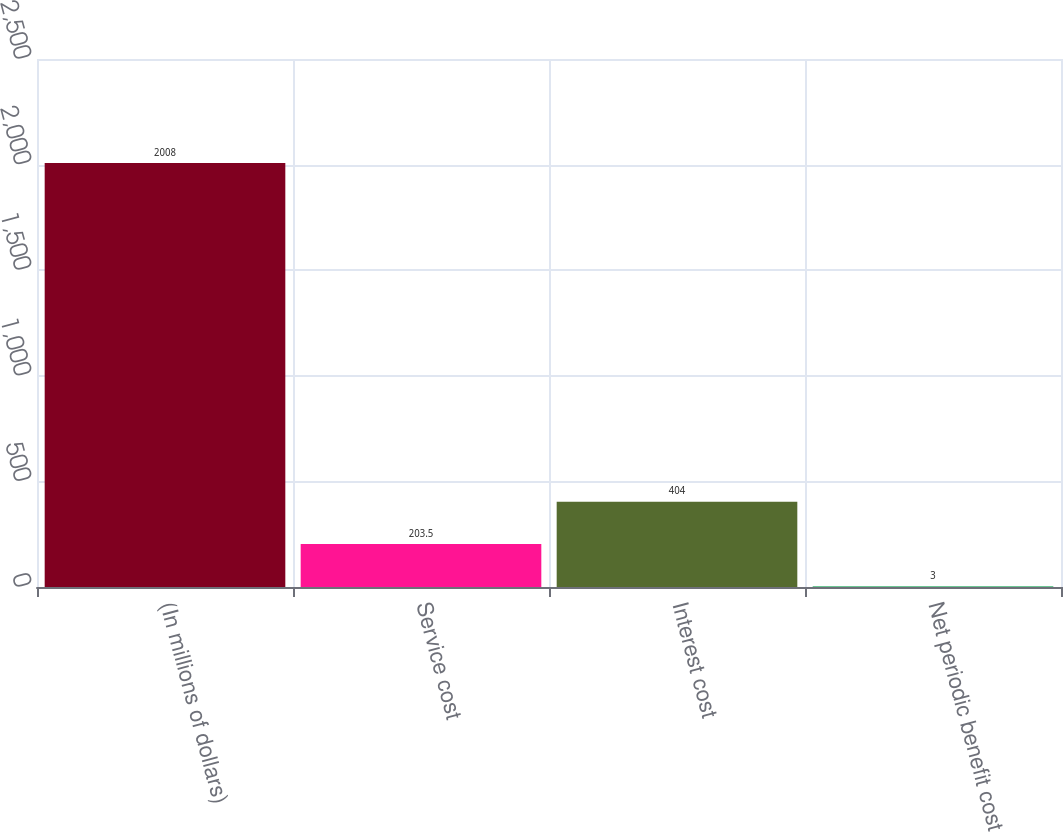Convert chart. <chart><loc_0><loc_0><loc_500><loc_500><bar_chart><fcel>(In millions of dollars)<fcel>Service cost<fcel>Interest cost<fcel>Net periodic benefit cost<nl><fcel>2008<fcel>203.5<fcel>404<fcel>3<nl></chart> 